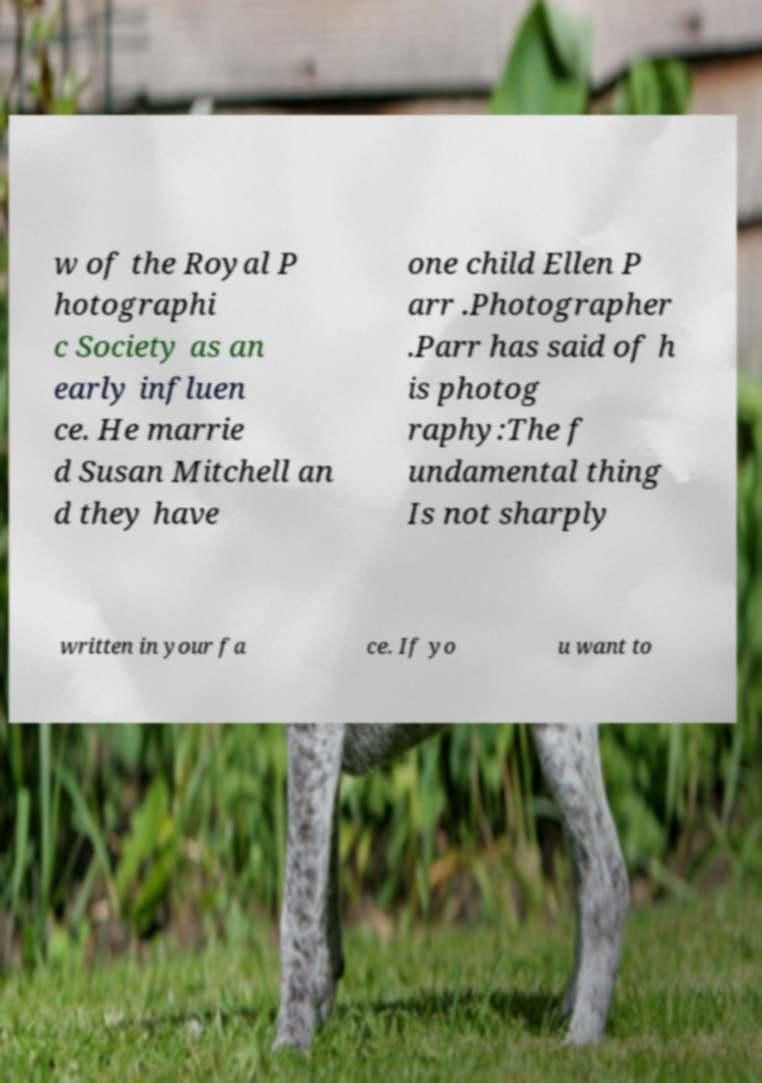Please identify and transcribe the text found in this image. w of the Royal P hotographi c Society as an early influen ce. He marrie d Susan Mitchell an d they have one child Ellen P arr .Photographer .Parr has said of h is photog raphy:The f undamental thing Is not sharply written in your fa ce. If yo u want to 